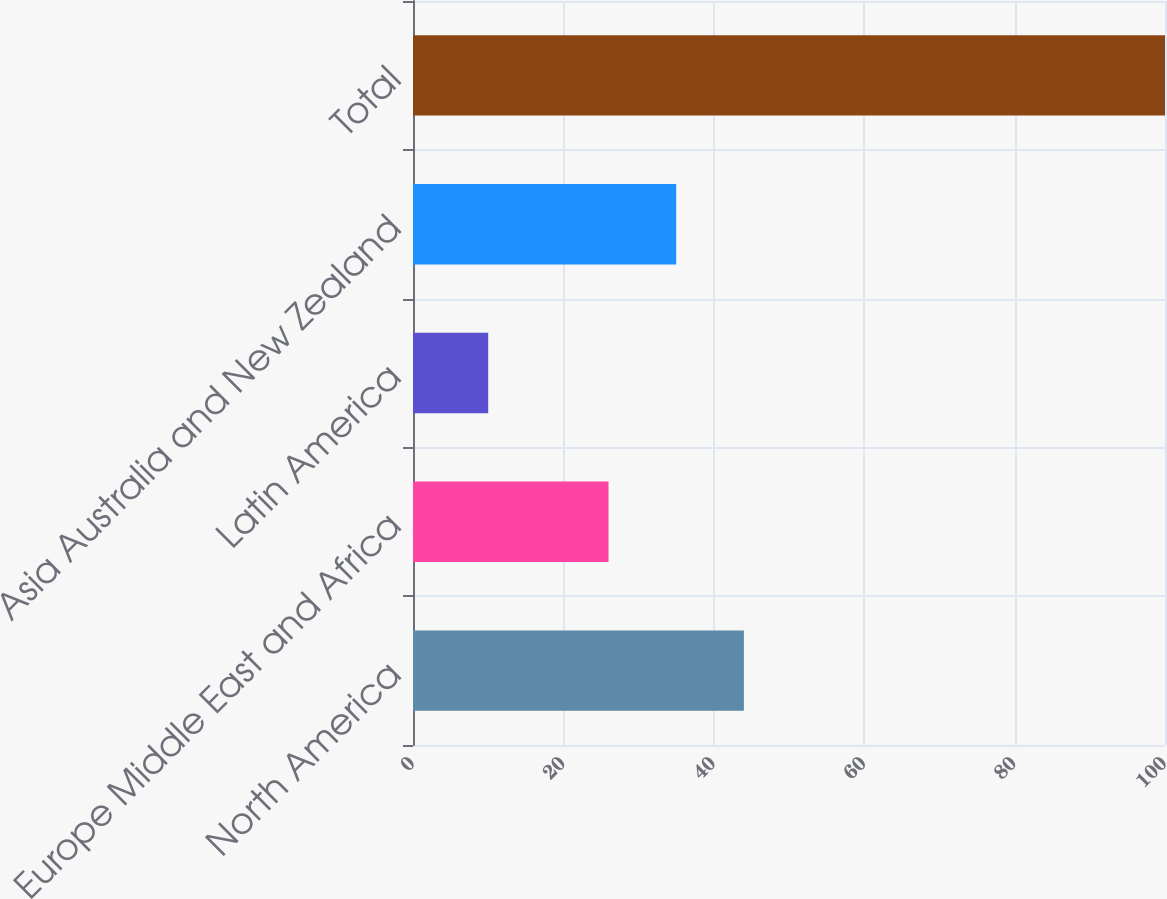Convert chart. <chart><loc_0><loc_0><loc_500><loc_500><bar_chart><fcel>North America<fcel>Europe Middle East and Africa<fcel>Latin America<fcel>Asia Australia and New Zealand<fcel>Total<nl><fcel>44<fcel>26<fcel>10<fcel>35<fcel>100<nl></chart> 